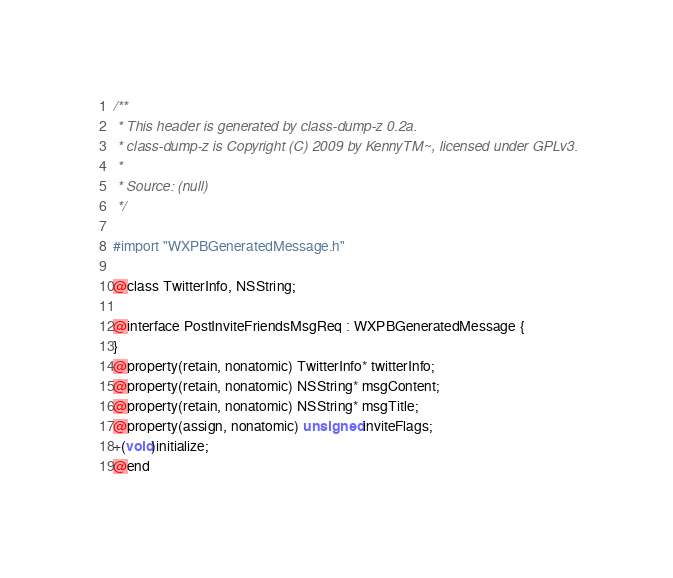Convert code to text. <code><loc_0><loc_0><loc_500><loc_500><_C_>/**
 * This header is generated by class-dump-z 0.2a.
 * class-dump-z is Copyright (C) 2009 by KennyTM~, licensed under GPLv3.
 *
 * Source: (null)
 */

#import "WXPBGeneratedMessage.h"

@class TwitterInfo, NSString;

@interface PostInviteFriendsMsgReq : WXPBGeneratedMessage {
}
@property(retain, nonatomic) TwitterInfo* twitterInfo;
@property(retain, nonatomic) NSString* msgContent;
@property(retain, nonatomic) NSString* msgTitle;
@property(assign, nonatomic) unsigned inviteFlags;
+(void)initialize;
@end

</code> 